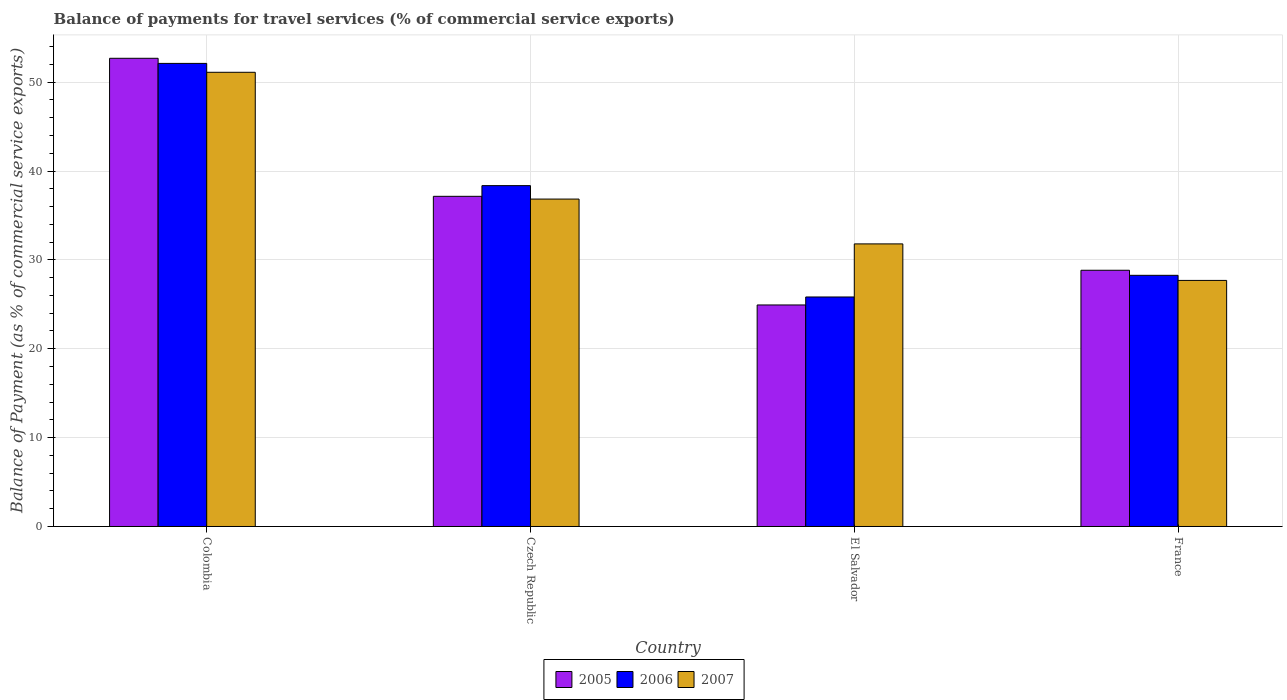How many different coloured bars are there?
Offer a very short reply. 3. Are the number of bars on each tick of the X-axis equal?
Keep it short and to the point. Yes. How many bars are there on the 2nd tick from the left?
Offer a very short reply. 3. What is the label of the 1st group of bars from the left?
Offer a terse response. Colombia. What is the balance of payments for travel services in 2007 in El Salvador?
Offer a terse response. 31.8. Across all countries, what is the maximum balance of payments for travel services in 2007?
Make the answer very short. 51.11. Across all countries, what is the minimum balance of payments for travel services in 2005?
Offer a terse response. 24.93. In which country was the balance of payments for travel services in 2006 maximum?
Provide a succinct answer. Colombia. In which country was the balance of payments for travel services in 2005 minimum?
Give a very brief answer. El Salvador. What is the total balance of payments for travel services in 2007 in the graph?
Offer a very short reply. 147.44. What is the difference between the balance of payments for travel services in 2006 in Colombia and that in Czech Republic?
Give a very brief answer. 13.76. What is the difference between the balance of payments for travel services in 2005 in Colombia and the balance of payments for travel services in 2007 in Czech Republic?
Your answer should be compact. 15.84. What is the average balance of payments for travel services in 2006 per country?
Provide a short and direct response. 36.14. What is the difference between the balance of payments for travel services of/in 2007 and balance of payments for travel services of/in 2005 in El Salvador?
Your answer should be compact. 6.87. In how many countries, is the balance of payments for travel services in 2007 greater than 12 %?
Make the answer very short. 4. What is the ratio of the balance of payments for travel services in 2006 in Colombia to that in El Salvador?
Make the answer very short. 2.02. Is the difference between the balance of payments for travel services in 2007 in Colombia and France greater than the difference between the balance of payments for travel services in 2005 in Colombia and France?
Your answer should be compact. No. What is the difference between the highest and the second highest balance of payments for travel services in 2007?
Provide a short and direct response. 14.27. What is the difference between the highest and the lowest balance of payments for travel services in 2005?
Your answer should be very brief. 27.76. Is the sum of the balance of payments for travel services in 2007 in El Salvador and France greater than the maximum balance of payments for travel services in 2006 across all countries?
Offer a very short reply. Yes. What does the 2nd bar from the left in France represents?
Give a very brief answer. 2006. What does the 1st bar from the right in El Salvador represents?
Make the answer very short. 2007. Is it the case that in every country, the sum of the balance of payments for travel services in 2006 and balance of payments for travel services in 2007 is greater than the balance of payments for travel services in 2005?
Your answer should be compact. Yes. How many bars are there?
Provide a succinct answer. 12. How many countries are there in the graph?
Your answer should be very brief. 4. Are the values on the major ticks of Y-axis written in scientific E-notation?
Provide a succinct answer. No. Where does the legend appear in the graph?
Offer a terse response. Bottom center. How many legend labels are there?
Make the answer very short. 3. What is the title of the graph?
Give a very brief answer. Balance of payments for travel services (% of commercial service exports). What is the label or title of the X-axis?
Provide a succinct answer. Country. What is the label or title of the Y-axis?
Ensure brevity in your answer.  Balance of Payment (as % of commercial service exports). What is the Balance of Payment (as % of commercial service exports) of 2005 in Colombia?
Provide a short and direct response. 52.69. What is the Balance of Payment (as % of commercial service exports) in 2006 in Colombia?
Your answer should be compact. 52.11. What is the Balance of Payment (as % of commercial service exports) of 2007 in Colombia?
Ensure brevity in your answer.  51.11. What is the Balance of Payment (as % of commercial service exports) of 2005 in Czech Republic?
Provide a short and direct response. 37.15. What is the Balance of Payment (as % of commercial service exports) in 2006 in Czech Republic?
Provide a short and direct response. 38.36. What is the Balance of Payment (as % of commercial service exports) in 2007 in Czech Republic?
Keep it short and to the point. 36.84. What is the Balance of Payment (as % of commercial service exports) in 2005 in El Salvador?
Your answer should be very brief. 24.93. What is the Balance of Payment (as % of commercial service exports) in 2006 in El Salvador?
Provide a succinct answer. 25.83. What is the Balance of Payment (as % of commercial service exports) of 2007 in El Salvador?
Give a very brief answer. 31.8. What is the Balance of Payment (as % of commercial service exports) in 2005 in France?
Keep it short and to the point. 28.83. What is the Balance of Payment (as % of commercial service exports) of 2006 in France?
Give a very brief answer. 28.26. What is the Balance of Payment (as % of commercial service exports) of 2007 in France?
Your answer should be compact. 27.69. Across all countries, what is the maximum Balance of Payment (as % of commercial service exports) in 2005?
Provide a short and direct response. 52.69. Across all countries, what is the maximum Balance of Payment (as % of commercial service exports) of 2006?
Provide a short and direct response. 52.11. Across all countries, what is the maximum Balance of Payment (as % of commercial service exports) in 2007?
Your response must be concise. 51.11. Across all countries, what is the minimum Balance of Payment (as % of commercial service exports) of 2005?
Ensure brevity in your answer.  24.93. Across all countries, what is the minimum Balance of Payment (as % of commercial service exports) in 2006?
Keep it short and to the point. 25.83. Across all countries, what is the minimum Balance of Payment (as % of commercial service exports) of 2007?
Your answer should be very brief. 27.69. What is the total Balance of Payment (as % of commercial service exports) of 2005 in the graph?
Offer a very short reply. 143.6. What is the total Balance of Payment (as % of commercial service exports) of 2006 in the graph?
Provide a short and direct response. 144.56. What is the total Balance of Payment (as % of commercial service exports) in 2007 in the graph?
Your answer should be compact. 147.44. What is the difference between the Balance of Payment (as % of commercial service exports) in 2005 in Colombia and that in Czech Republic?
Your response must be concise. 15.53. What is the difference between the Balance of Payment (as % of commercial service exports) in 2006 in Colombia and that in Czech Republic?
Offer a very short reply. 13.76. What is the difference between the Balance of Payment (as % of commercial service exports) of 2007 in Colombia and that in Czech Republic?
Your answer should be compact. 14.27. What is the difference between the Balance of Payment (as % of commercial service exports) in 2005 in Colombia and that in El Salvador?
Your response must be concise. 27.76. What is the difference between the Balance of Payment (as % of commercial service exports) in 2006 in Colombia and that in El Salvador?
Your answer should be very brief. 26.28. What is the difference between the Balance of Payment (as % of commercial service exports) in 2007 in Colombia and that in El Salvador?
Make the answer very short. 19.31. What is the difference between the Balance of Payment (as % of commercial service exports) of 2005 in Colombia and that in France?
Give a very brief answer. 23.85. What is the difference between the Balance of Payment (as % of commercial service exports) in 2006 in Colombia and that in France?
Your answer should be compact. 23.85. What is the difference between the Balance of Payment (as % of commercial service exports) of 2007 in Colombia and that in France?
Offer a very short reply. 23.42. What is the difference between the Balance of Payment (as % of commercial service exports) of 2005 in Czech Republic and that in El Salvador?
Offer a very short reply. 12.22. What is the difference between the Balance of Payment (as % of commercial service exports) in 2006 in Czech Republic and that in El Salvador?
Give a very brief answer. 12.53. What is the difference between the Balance of Payment (as % of commercial service exports) in 2007 in Czech Republic and that in El Salvador?
Keep it short and to the point. 5.04. What is the difference between the Balance of Payment (as % of commercial service exports) in 2005 in Czech Republic and that in France?
Keep it short and to the point. 8.32. What is the difference between the Balance of Payment (as % of commercial service exports) in 2006 in Czech Republic and that in France?
Give a very brief answer. 10.09. What is the difference between the Balance of Payment (as % of commercial service exports) in 2007 in Czech Republic and that in France?
Offer a very short reply. 9.15. What is the difference between the Balance of Payment (as % of commercial service exports) of 2005 in El Salvador and that in France?
Provide a short and direct response. -3.91. What is the difference between the Balance of Payment (as % of commercial service exports) of 2006 in El Salvador and that in France?
Provide a succinct answer. -2.44. What is the difference between the Balance of Payment (as % of commercial service exports) of 2007 in El Salvador and that in France?
Provide a succinct answer. 4.11. What is the difference between the Balance of Payment (as % of commercial service exports) of 2005 in Colombia and the Balance of Payment (as % of commercial service exports) of 2006 in Czech Republic?
Your answer should be compact. 14.33. What is the difference between the Balance of Payment (as % of commercial service exports) of 2005 in Colombia and the Balance of Payment (as % of commercial service exports) of 2007 in Czech Republic?
Give a very brief answer. 15.84. What is the difference between the Balance of Payment (as % of commercial service exports) of 2006 in Colombia and the Balance of Payment (as % of commercial service exports) of 2007 in Czech Republic?
Your answer should be very brief. 15.27. What is the difference between the Balance of Payment (as % of commercial service exports) of 2005 in Colombia and the Balance of Payment (as % of commercial service exports) of 2006 in El Salvador?
Offer a very short reply. 26.86. What is the difference between the Balance of Payment (as % of commercial service exports) in 2005 in Colombia and the Balance of Payment (as % of commercial service exports) in 2007 in El Salvador?
Make the answer very short. 20.89. What is the difference between the Balance of Payment (as % of commercial service exports) of 2006 in Colombia and the Balance of Payment (as % of commercial service exports) of 2007 in El Salvador?
Your answer should be very brief. 20.31. What is the difference between the Balance of Payment (as % of commercial service exports) of 2005 in Colombia and the Balance of Payment (as % of commercial service exports) of 2006 in France?
Offer a very short reply. 24.42. What is the difference between the Balance of Payment (as % of commercial service exports) in 2005 in Colombia and the Balance of Payment (as % of commercial service exports) in 2007 in France?
Make the answer very short. 25. What is the difference between the Balance of Payment (as % of commercial service exports) in 2006 in Colombia and the Balance of Payment (as % of commercial service exports) in 2007 in France?
Keep it short and to the point. 24.42. What is the difference between the Balance of Payment (as % of commercial service exports) of 2005 in Czech Republic and the Balance of Payment (as % of commercial service exports) of 2006 in El Salvador?
Provide a short and direct response. 11.33. What is the difference between the Balance of Payment (as % of commercial service exports) in 2005 in Czech Republic and the Balance of Payment (as % of commercial service exports) in 2007 in El Salvador?
Your answer should be compact. 5.35. What is the difference between the Balance of Payment (as % of commercial service exports) in 2006 in Czech Republic and the Balance of Payment (as % of commercial service exports) in 2007 in El Salvador?
Make the answer very short. 6.56. What is the difference between the Balance of Payment (as % of commercial service exports) of 2005 in Czech Republic and the Balance of Payment (as % of commercial service exports) of 2006 in France?
Your answer should be very brief. 8.89. What is the difference between the Balance of Payment (as % of commercial service exports) in 2005 in Czech Republic and the Balance of Payment (as % of commercial service exports) in 2007 in France?
Offer a very short reply. 9.46. What is the difference between the Balance of Payment (as % of commercial service exports) in 2006 in Czech Republic and the Balance of Payment (as % of commercial service exports) in 2007 in France?
Provide a succinct answer. 10.67. What is the difference between the Balance of Payment (as % of commercial service exports) of 2005 in El Salvador and the Balance of Payment (as % of commercial service exports) of 2006 in France?
Give a very brief answer. -3.33. What is the difference between the Balance of Payment (as % of commercial service exports) in 2005 in El Salvador and the Balance of Payment (as % of commercial service exports) in 2007 in France?
Your answer should be very brief. -2.76. What is the difference between the Balance of Payment (as % of commercial service exports) in 2006 in El Salvador and the Balance of Payment (as % of commercial service exports) in 2007 in France?
Keep it short and to the point. -1.86. What is the average Balance of Payment (as % of commercial service exports) of 2005 per country?
Your response must be concise. 35.9. What is the average Balance of Payment (as % of commercial service exports) of 2006 per country?
Ensure brevity in your answer.  36.14. What is the average Balance of Payment (as % of commercial service exports) in 2007 per country?
Give a very brief answer. 36.86. What is the difference between the Balance of Payment (as % of commercial service exports) in 2005 and Balance of Payment (as % of commercial service exports) in 2006 in Colombia?
Make the answer very short. 0.58. What is the difference between the Balance of Payment (as % of commercial service exports) in 2005 and Balance of Payment (as % of commercial service exports) in 2007 in Colombia?
Make the answer very short. 1.58. What is the difference between the Balance of Payment (as % of commercial service exports) in 2005 and Balance of Payment (as % of commercial service exports) in 2006 in Czech Republic?
Give a very brief answer. -1.2. What is the difference between the Balance of Payment (as % of commercial service exports) in 2005 and Balance of Payment (as % of commercial service exports) in 2007 in Czech Republic?
Ensure brevity in your answer.  0.31. What is the difference between the Balance of Payment (as % of commercial service exports) in 2006 and Balance of Payment (as % of commercial service exports) in 2007 in Czech Republic?
Keep it short and to the point. 1.51. What is the difference between the Balance of Payment (as % of commercial service exports) of 2005 and Balance of Payment (as % of commercial service exports) of 2006 in El Salvador?
Your answer should be compact. -0.9. What is the difference between the Balance of Payment (as % of commercial service exports) of 2005 and Balance of Payment (as % of commercial service exports) of 2007 in El Salvador?
Provide a succinct answer. -6.87. What is the difference between the Balance of Payment (as % of commercial service exports) of 2006 and Balance of Payment (as % of commercial service exports) of 2007 in El Salvador?
Offer a very short reply. -5.97. What is the difference between the Balance of Payment (as % of commercial service exports) in 2005 and Balance of Payment (as % of commercial service exports) in 2006 in France?
Your response must be concise. 0.57. What is the difference between the Balance of Payment (as % of commercial service exports) in 2005 and Balance of Payment (as % of commercial service exports) in 2007 in France?
Offer a very short reply. 1.14. What is the difference between the Balance of Payment (as % of commercial service exports) of 2006 and Balance of Payment (as % of commercial service exports) of 2007 in France?
Offer a very short reply. 0.57. What is the ratio of the Balance of Payment (as % of commercial service exports) in 2005 in Colombia to that in Czech Republic?
Provide a short and direct response. 1.42. What is the ratio of the Balance of Payment (as % of commercial service exports) of 2006 in Colombia to that in Czech Republic?
Make the answer very short. 1.36. What is the ratio of the Balance of Payment (as % of commercial service exports) in 2007 in Colombia to that in Czech Republic?
Offer a very short reply. 1.39. What is the ratio of the Balance of Payment (as % of commercial service exports) in 2005 in Colombia to that in El Salvador?
Keep it short and to the point. 2.11. What is the ratio of the Balance of Payment (as % of commercial service exports) in 2006 in Colombia to that in El Salvador?
Your response must be concise. 2.02. What is the ratio of the Balance of Payment (as % of commercial service exports) in 2007 in Colombia to that in El Salvador?
Your answer should be very brief. 1.61. What is the ratio of the Balance of Payment (as % of commercial service exports) in 2005 in Colombia to that in France?
Provide a succinct answer. 1.83. What is the ratio of the Balance of Payment (as % of commercial service exports) of 2006 in Colombia to that in France?
Your response must be concise. 1.84. What is the ratio of the Balance of Payment (as % of commercial service exports) in 2007 in Colombia to that in France?
Provide a succinct answer. 1.85. What is the ratio of the Balance of Payment (as % of commercial service exports) of 2005 in Czech Republic to that in El Salvador?
Offer a very short reply. 1.49. What is the ratio of the Balance of Payment (as % of commercial service exports) of 2006 in Czech Republic to that in El Salvador?
Offer a terse response. 1.49. What is the ratio of the Balance of Payment (as % of commercial service exports) in 2007 in Czech Republic to that in El Salvador?
Give a very brief answer. 1.16. What is the ratio of the Balance of Payment (as % of commercial service exports) of 2005 in Czech Republic to that in France?
Offer a very short reply. 1.29. What is the ratio of the Balance of Payment (as % of commercial service exports) in 2006 in Czech Republic to that in France?
Ensure brevity in your answer.  1.36. What is the ratio of the Balance of Payment (as % of commercial service exports) in 2007 in Czech Republic to that in France?
Offer a very short reply. 1.33. What is the ratio of the Balance of Payment (as % of commercial service exports) of 2005 in El Salvador to that in France?
Offer a terse response. 0.86. What is the ratio of the Balance of Payment (as % of commercial service exports) in 2006 in El Salvador to that in France?
Your answer should be compact. 0.91. What is the ratio of the Balance of Payment (as % of commercial service exports) in 2007 in El Salvador to that in France?
Keep it short and to the point. 1.15. What is the difference between the highest and the second highest Balance of Payment (as % of commercial service exports) of 2005?
Ensure brevity in your answer.  15.53. What is the difference between the highest and the second highest Balance of Payment (as % of commercial service exports) of 2006?
Keep it short and to the point. 13.76. What is the difference between the highest and the second highest Balance of Payment (as % of commercial service exports) in 2007?
Your response must be concise. 14.27. What is the difference between the highest and the lowest Balance of Payment (as % of commercial service exports) in 2005?
Your answer should be compact. 27.76. What is the difference between the highest and the lowest Balance of Payment (as % of commercial service exports) of 2006?
Make the answer very short. 26.28. What is the difference between the highest and the lowest Balance of Payment (as % of commercial service exports) of 2007?
Provide a succinct answer. 23.42. 